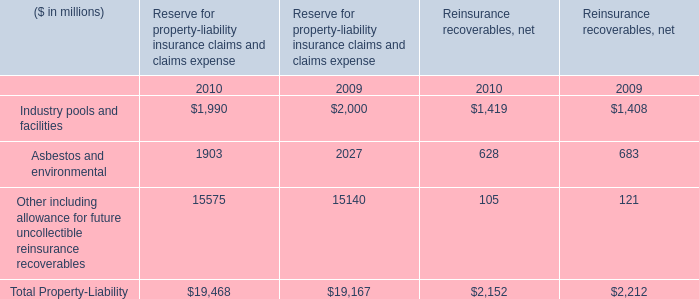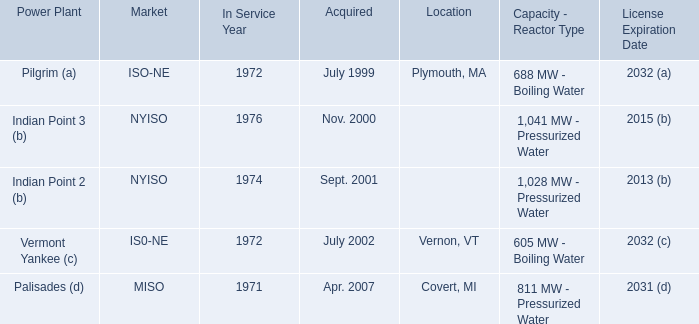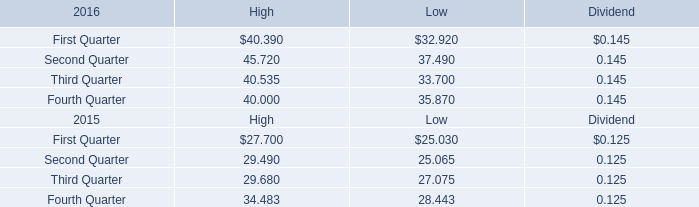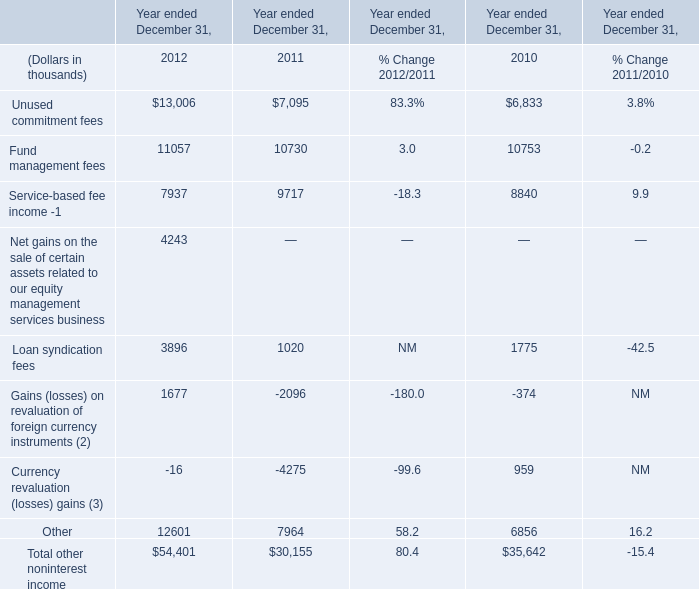What was the average of the Loan syndication fees in the years where Unused commitment fees is positive? (in thousand) 
Computations: ((3896 + 1020) / 2)
Answer: 2458.0. 